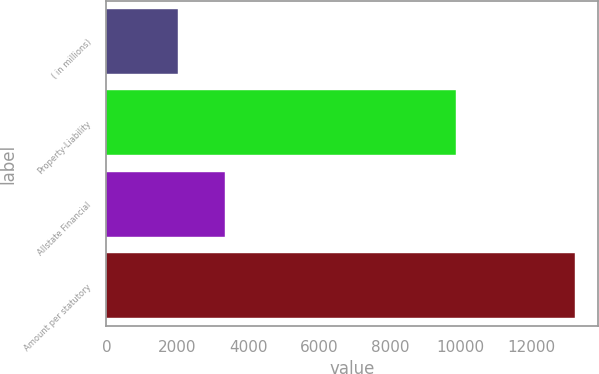Convert chart. <chart><loc_0><loc_0><loc_500><loc_500><bar_chart><fcel>( in millions)<fcel>Property-Liability<fcel>Allstate Financial<fcel>Amount per statutory<nl><fcel>2008<fcel>9878<fcel>3335<fcel>13213<nl></chart> 